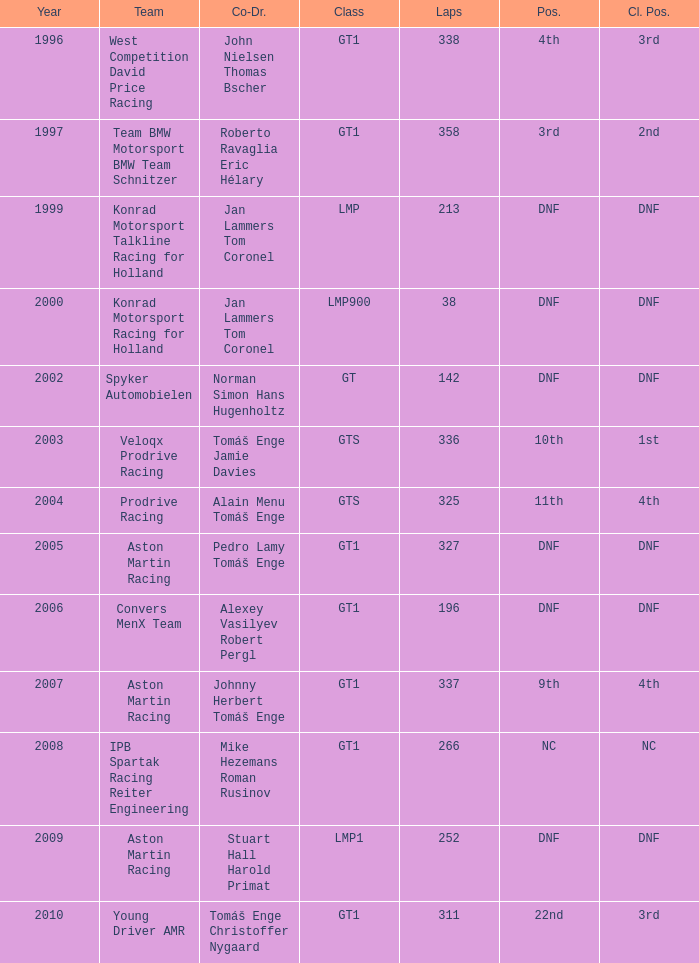Which position finished 3rd in class and completed less than 338 laps? 22nd. 